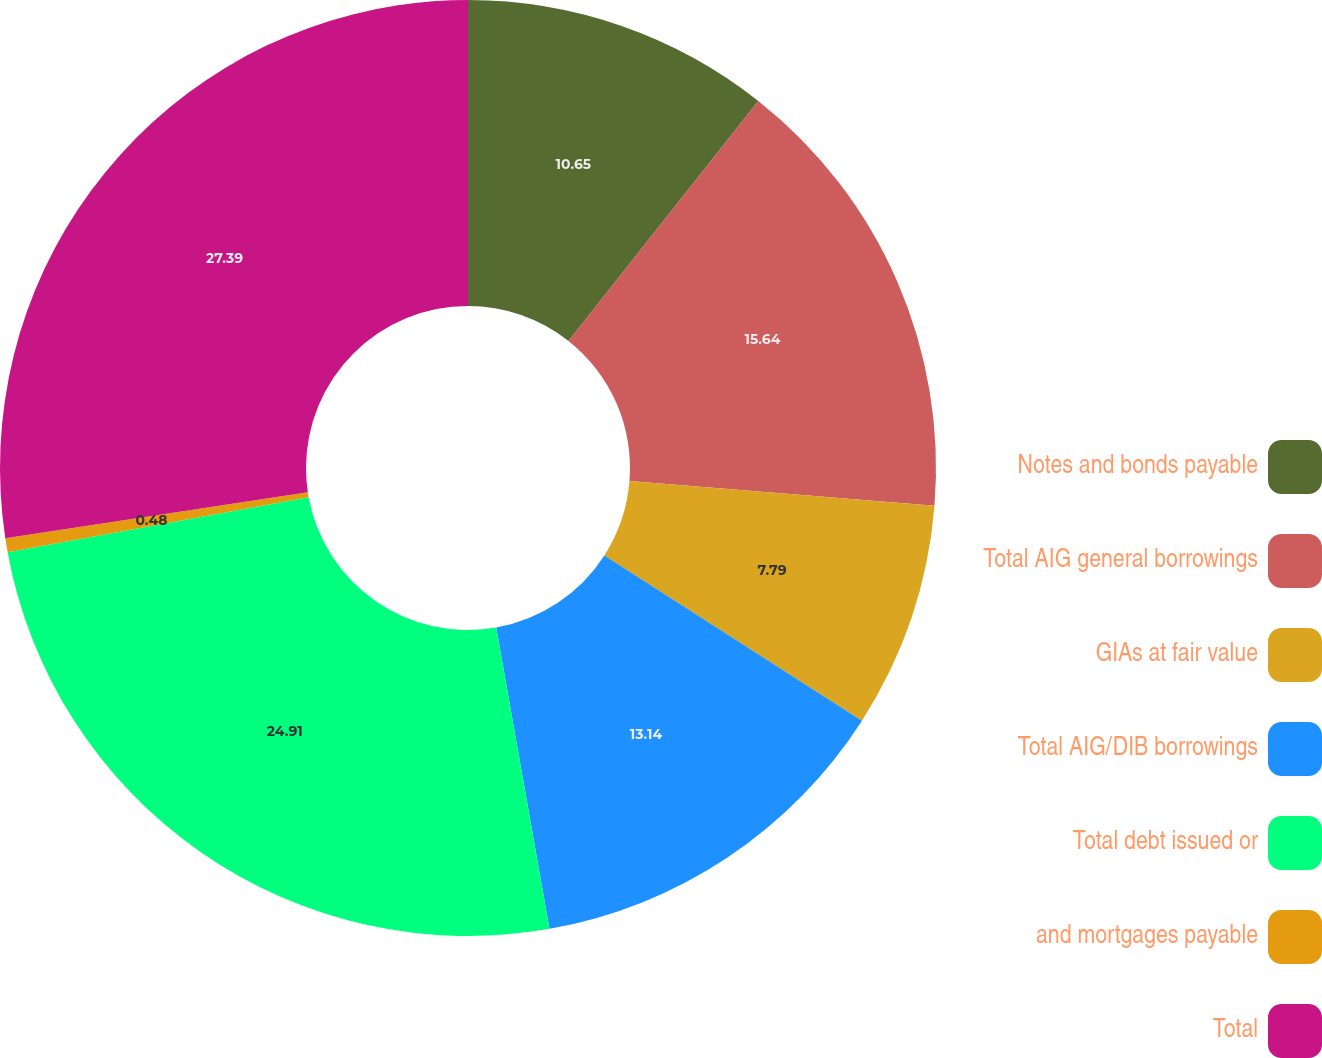Convert chart. <chart><loc_0><loc_0><loc_500><loc_500><pie_chart><fcel>Notes and bonds payable<fcel>Total AIG general borrowings<fcel>GIAs at fair value<fcel>Total AIG/DIB borrowings<fcel>Total debt issued or<fcel>and mortgages payable<fcel>Total<nl><fcel>10.65%<fcel>15.64%<fcel>7.79%<fcel>13.14%<fcel>24.91%<fcel>0.48%<fcel>27.4%<nl></chart> 